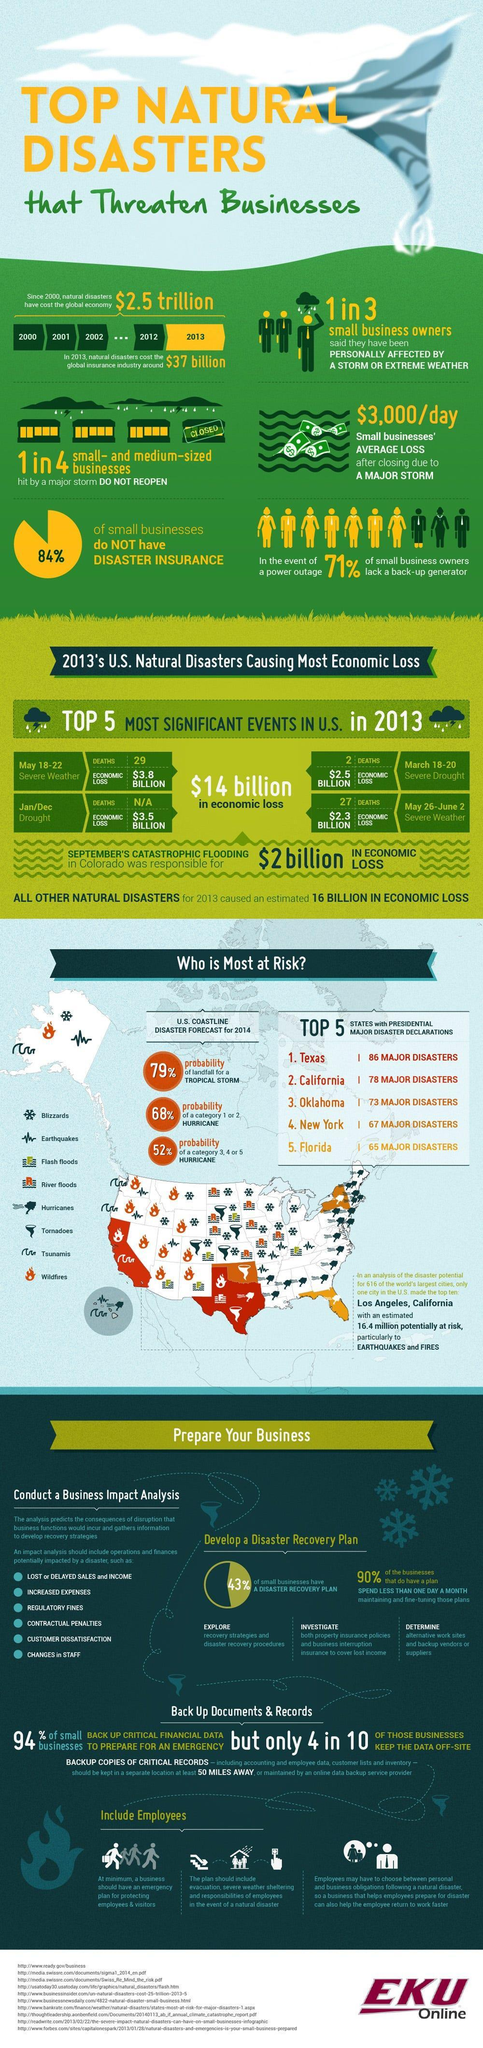How many people were killed by severe drought in the U.S. during March 18-20, 2013?
Answer the question with a short phrase. 2 How many people were killed by the severe weather conditions in the U.S. during May 18- 22, 2013? 29 How many people were killed by the severe weather conditions in the U.S. during May 26- June 2, 2013? 27 What percent of the small businesses do not have a disaster recovery plan? 57% What is the probability of a category 1 or 2 hurricane in the U.S. coastline in 2014? 68% What percent of small businesses have a disaster insurance? 16% What is the economic loss (in billions) caused by the severe weather conditions in the U.S. during May 26- June 2, 2013? $2.3 What is the economic loss (in billions) caused by drought in the U.S. in January/December 2013? $3.5 What is the probability of a category 3,4 or 5 hurricane in the U.S. coastline in 2014? 52% 